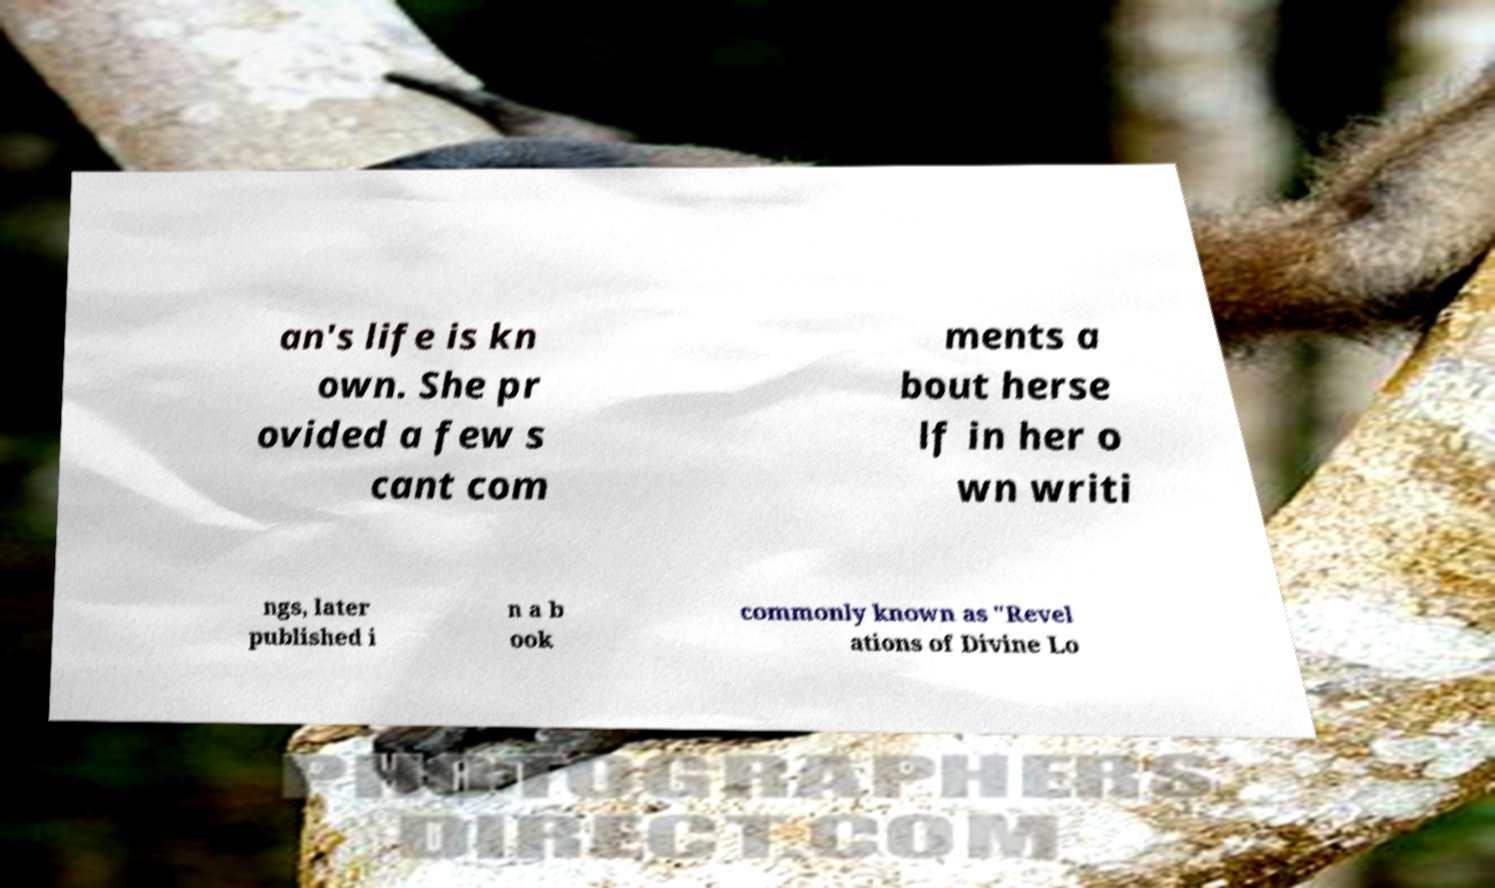What messages or text are displayed in this image? I need them in a readable, typed format. an's life is kn own. She pr ovided a few s cant com ments a bout herse lf in her o wn writi ngs, later published i n a b ook commonly known as "Revel ations of Divine Lo 